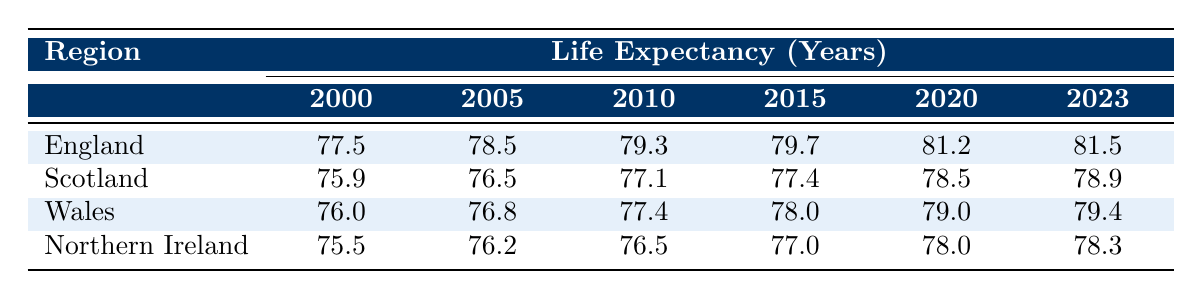What was the life expectancy in England in 2010? The table lists the life expectancy for England in 2010 as 79.3 years.
Answer: 79.3 Which region had the highest life expectancy in 2020? In 2020, England had the highest life expectancy at 81.2 years, compared to Scotland (78.5), Wales (79.0), and Northern Ireland (78.0).
Answer: England What is the difference in life expectancy between Scotland in 2000 and in 2023? In 2000, life's expectancy in Scotland was 75.9 years and in 2023 it was 78.9 years. The difference is 78.9 - 75.9 = 3.0 years.
Answer: 3.0 Did life expectancy in Wales increase every five years from 2000 to 2023? Checking each year: 2000 (76.0) to 2005 (76.8) is an increase, 2005 to 2010 (77.4) is an increase, 2010 to 2015 (78.0) is an increase, 2015 to 2020 (79.0) is an increase, and 2020 to 2023 (79.4) is an increase. Therefore, yes, it increased every five years.
Answer: Yes What is the average life expectancy in Northern Ireland from 2000 to 2023? Adding up the life expectancies: 75.5 + 76.2 + 76.5 + 77.0 + 78.0 + 78.3 = 462.5. There are 6 years, so the average is 462.5 / 6 = 77.08 years.
Answer: 77.08 